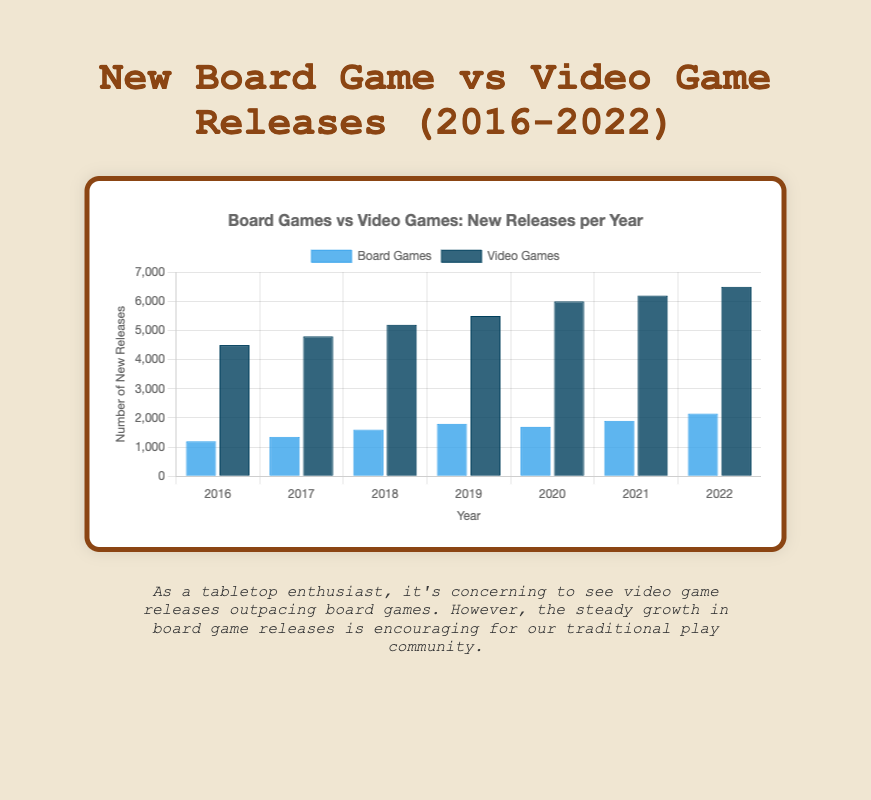Which year saw the highest number of new board game releases? Look at the heights of the blue bars representing board game releases over the years. Identify the tallest blue bar.
Answer: 2022 What's the difference in the number of new video game releases between 2021 and 2020? Subtract the height of the dark blue bar in 2020 from the height of the dark blue bar in 2021. Specifically, 6200 (2021) - 6000 (2020) = 200.
Answer: 200 Which year had the smallest increase in new board game releases compared to the previous year? Compare the blue bars for each consecutive year and find the smallest difference. The differences are: 
2017-2016: 1350 - 1200 = 150,
2018-2017: 1600 - 1350 = 250,
2019-2018: 1800 - 1600 = 200,
2020-2019: 1700 - 1800 = -100,
2021-2020: 1900 - 1700 = 200,
2022-2021: 2150 - 1900 = 250.
2020 has a decrease, but the smallest increase is in 2017 with 150 new releases compared to 2016.
Answer: 2017 By how much did the number of new video game releases increase from 2017 to 2022? Subtract the height of the dark blue bar in 2017 from the height of the dark blue bar in 2022. Specifically, 6500 (2022) - 4800 (2017) = 1700.
Answer: 1700 In which year was the gap between new board game releases and new video game releases the largest, and what was the gap? Calculate the differences between the heights of the blue and dark blue bars for each year. The differences are:
2016: 4500 - 1200 = 3300,
2017: 4800 - 1350 = 3450,
2018: 5200 - 1600 = 3600,
2019: 5500 - 1800 = 3700,
2020: 6000 - 1700 = 4300,
2021: 6200 - 1900 = 4300,
2022: 6500 - 2150 = 4350.
The largest gap is in 2022 with a difference of 4350.
Answer: 2022, 4350 What is the average number of new video game releases per year between 2016 and 2022? Sum the new video game releases for each year and divide by the number of years (7). The sum is 4500 + 4800 + 5200 + 5500 + 6000 + 6200 + 6500 = 38700. The average is 38700 / 7 = 5528.57.
Answer: 5528.57 How many more new board games were released in 2022 compared to 2019? Subtract the height of the blue bar in 2019 from the height of the blue bar in 2022. Specifically, 2150 (2022) - 1800 (2019) = 350.
Answer: 350 In which year did the number of new board game releases decrease compared to the previous year? Compare the heights of the blue bars for each consecutive year. The height in 2020 (1700) is less than in 2019 (1800).
Answer: 2020 